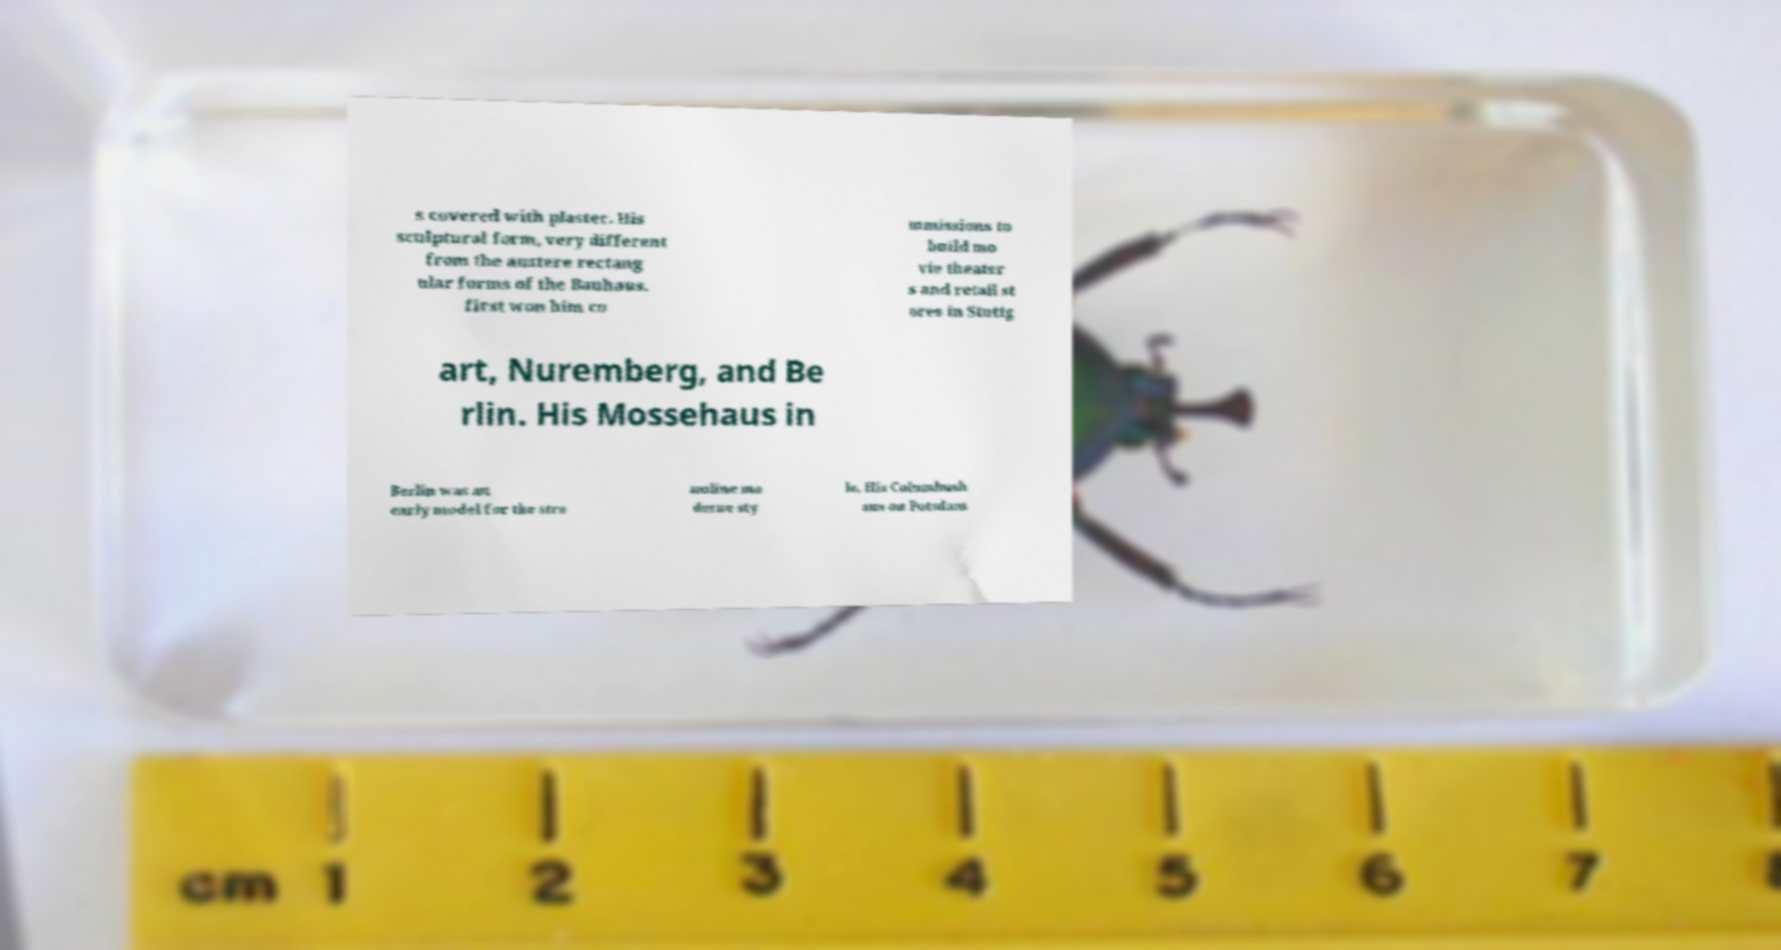Can you read and provide the text displayed in the image?This photo seems to have some interesting text. Can you extract and type it out for me? s covered with plaster. His sculptural form, very different from the austere rectang ular forms of the Bauhaus, first won him co mmissions to build mo vie theater s and retail st ores in Stuttg art, Nuremberg, and Be rlin. His Mossehaus in Berlin was an early model for the stre amline mo derne sty le. His Columbush aus on Potsdam 